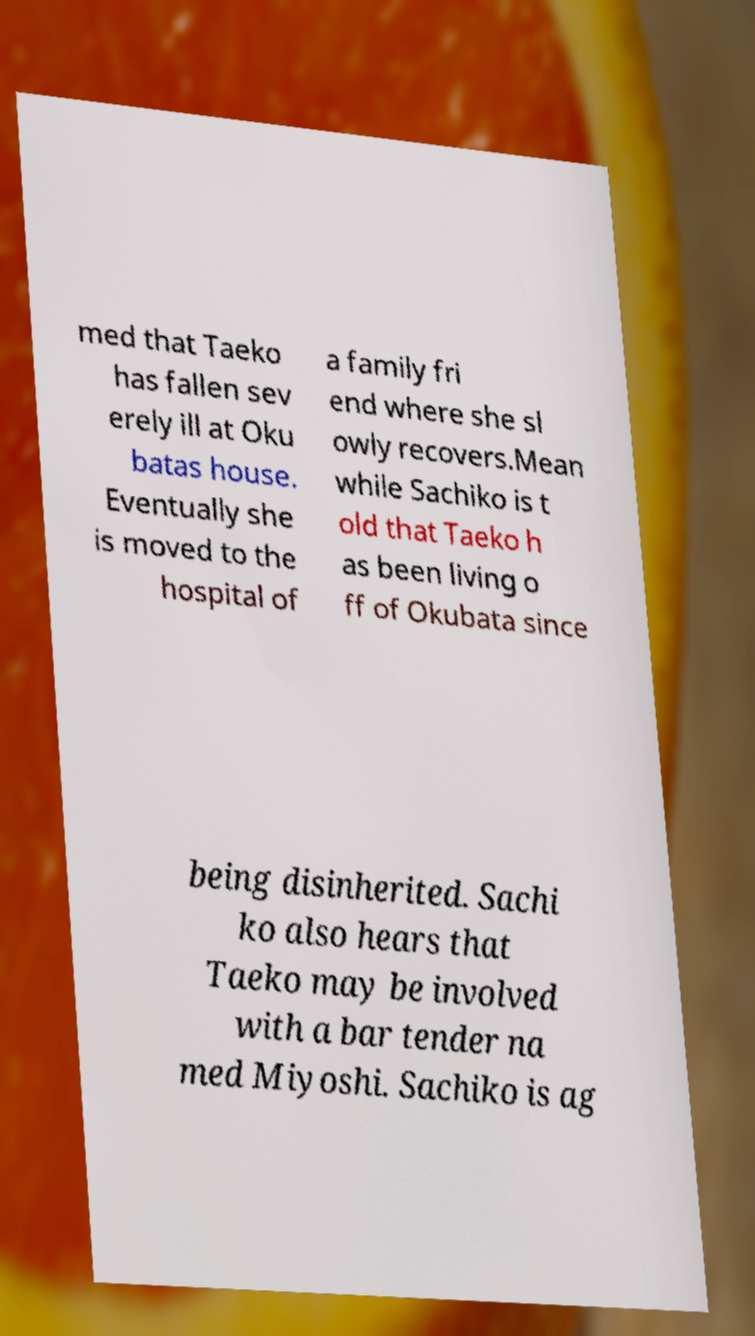Can you read and provide the text displayed in the image?This photo seems to have some interesting text. Can you extract and type it out for me? med that Taeko has fallen sev erely ill at Oku batas house. Eventually she is moved to the hospital of a family fri end where she sl owly recovers.Mean while Sachiko is t old that Taeko h as been living o ff of Okubata since being disinherited. Sachi ko also hears that Taeko may be involved with a bar tender na med Miyoshi. Sachiko is ag 